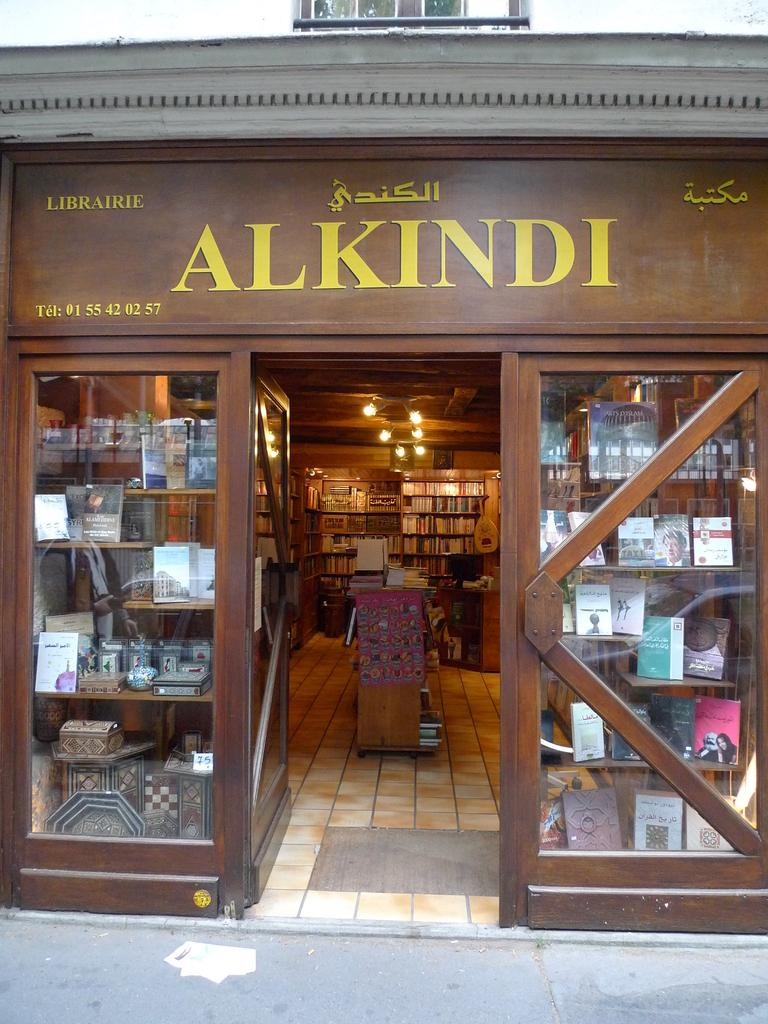<image>
Create a compact narrative representing the image presented. The front of a bookstore that is called Alkindi. 